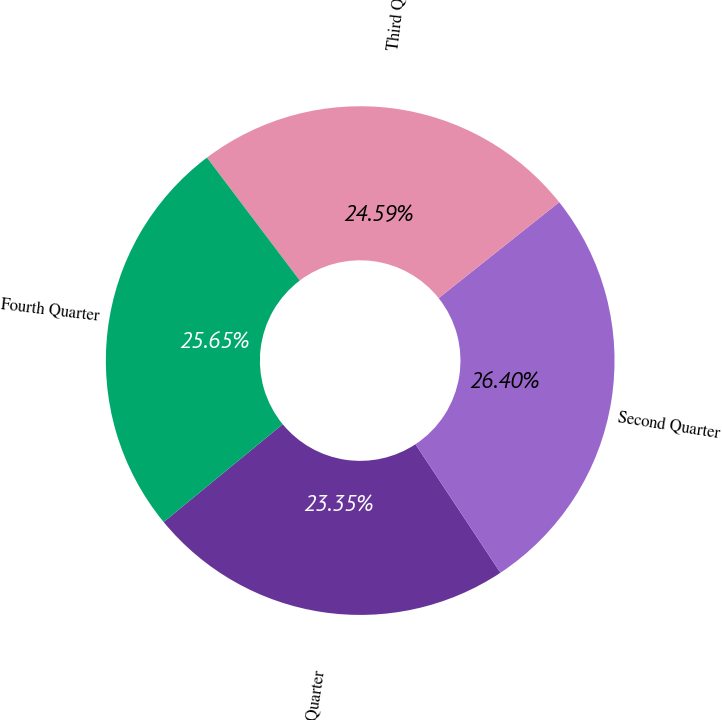<chart> <loc_0><loc_0><loc_500><loc_500><pie_chart><fcel>First Quarter<fcel>Second Quarter<fcel>Third Quarter<fcel>Fourth Quarter<nl><fcel>23.35%<fcel>26.4%<fcel>24.59%<fcel>25.65%<nl></chart> 